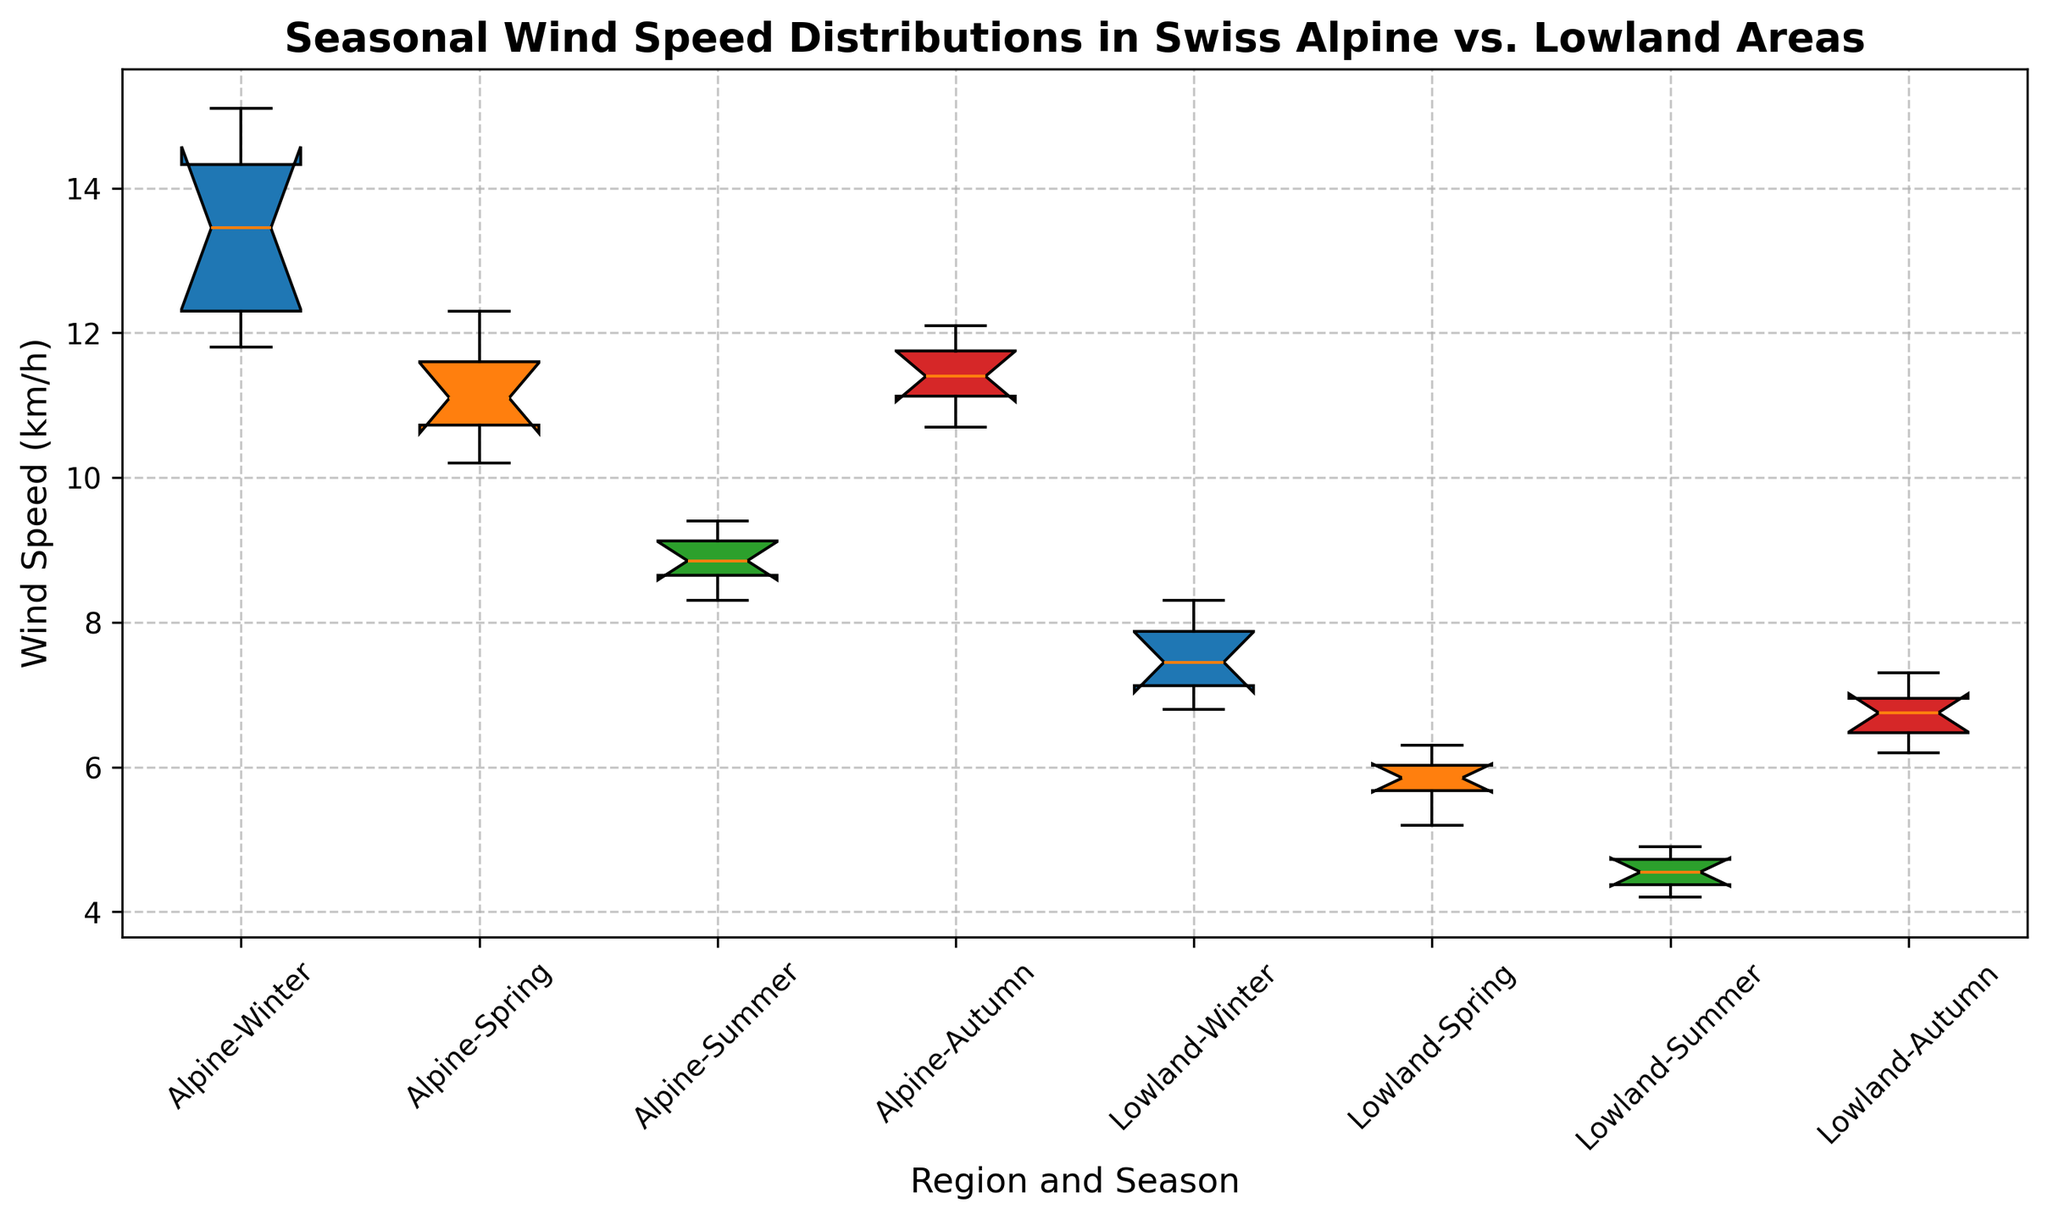How does the median wind speed in the Alpine region during Winter compare to the Lowland region during Winter? The box plot shows the median as a line within each box. You can observe that the median line for the Alpine region in Winter is positioned higher on the y-axis compared to the median line for the Lowland region in Winter.
Answer: Alpine region has a higher median wind speed in Winter Which season has the highest median wind speed in both the Alpine and Lowland regions? By comparing the median lines of the boxes for each season in both regions, you can see which ones are positioned the highest on the y-axis.
Answer: Winter What's the range of wind speeds for the Lowland region in Summer? The range is determined by the difference between the maximum and minimum values shown by the whiskers of the box plot for the Lowland Summer section. Observing their positions on the y-axis gives us the values to calculate the range.
Answer: 3.1 km/h (4.9 - 1.8) Compare the interquartile range (IQR) of wind speeds in Spring for Alpine and Lowland regions. Which one is greater? The IQR is the height of the box, representing the middle 50% of the data. By visually comparing the height of the boxes for Spring in both regions, one can determine which one is larger.
Answer: Alpine region How do the median wind speeds in the Alpine region in Autumn and Summer compare? Look at the position of the median line inside the boxes for Autumn and Summer in the Alpine region. The higher median line indicates a higher median wind speed.
Answer: Autumn has a higher median than Summer Which season in the Lowland region has the narrowest distribution of wind speeds? The narrowest distribution corresponds to the smallest height of the box and whiskers. By visually comparing their heights, you can identify the season.
Answer: Summer Identify which region and season combination has the widest range of wind speeds. The widest range is indicated by the tallest whiskers. By comparing all the whiskers' heights in the plot, you can find the widest range.
Answer: Alpine Winter Which season shows a decrease in median wind speed from Winter to Spring for both regions? Track the position of the median line from Winter to Spring for both regions. If the median line shifts downward, it signifies a decrease.
Answer: Spring In which season does the Alpine region have a larger variance in wind speeds compared to the Lowland region? Variance can be inferred from the spread of the box and whiskers. A larger box and whiskers indicate higher variance. By comparing their spreads, you can identify the season.
Answer: Winter Are there any seasons where the wind speeds for the Alpine and Lowland regions are relatively similar? Look at the positions of the boxes and their median lines across both regions for each season. Seasons where they align closely indicate similar wind speeds.
Answer: Spring and, to some extent, Autumn 